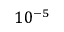<formula> <loc_0><loc_0><loc_500><loc_500>1 0 ^ { - 5 }</formula> 